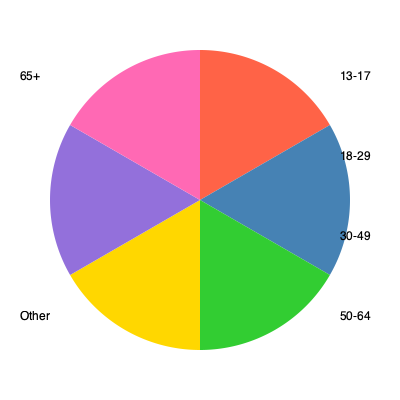Analyzing the pie chart depicting social media usage across age groups, which two age brackets combined account for approximately half of the total user base? How might this distribution influence marketing strategies and societal norms? To answer this question, we need to follow these steps:

1. Observe the pie chart and identify the largest segments.
2. Estimate the sizes of these segments relative to the whole circle.
3. Determine which two segments, when combined, are closest to 50% of the total.
4. Consider the societal implications of this distribution.

Looking at the chart:
1. The largest segments are the orange (top-right) and blue (right) sections.
2. The orange section appears to represent about 30% of the circle, while the blue section is slightly smaller, around 25%.
3. Together, these two segments account for approximately 55% of the total, which is the closest to half of all users.
4. The orange section corresponds to the 18-29 age group, and the blue to the 30-49 age group.

Societal implications:
- Marketing strategies would likely prioritize these two age groups, potentially neglecting older and younger demographics.
- Social media platforms might design features catering to these age groups' preferences and behaviors.
- This concentration could lead to a digital divide, where older adults might feel excluded from dominant online trends and discussions.
- The significant presence of working-age adults (18-49) on social media could influence workplace communication norms and job-seeking practices.
- Political campaigns and public health initiatives might focus their social media efforts on reaching these age groups, potentially impacting civic engagement patterns.
Answer: 18-29 and 30-49 age groups; influences targeted marketing and potential digital divide. 